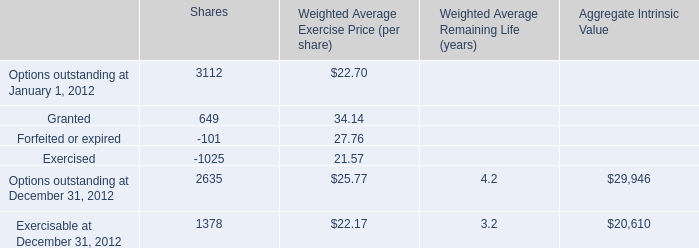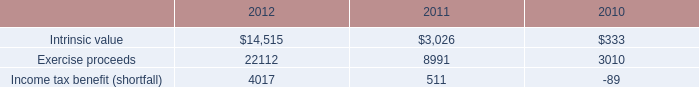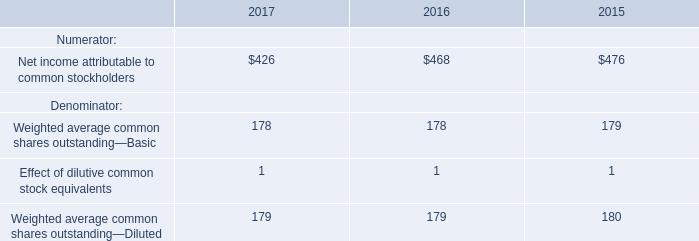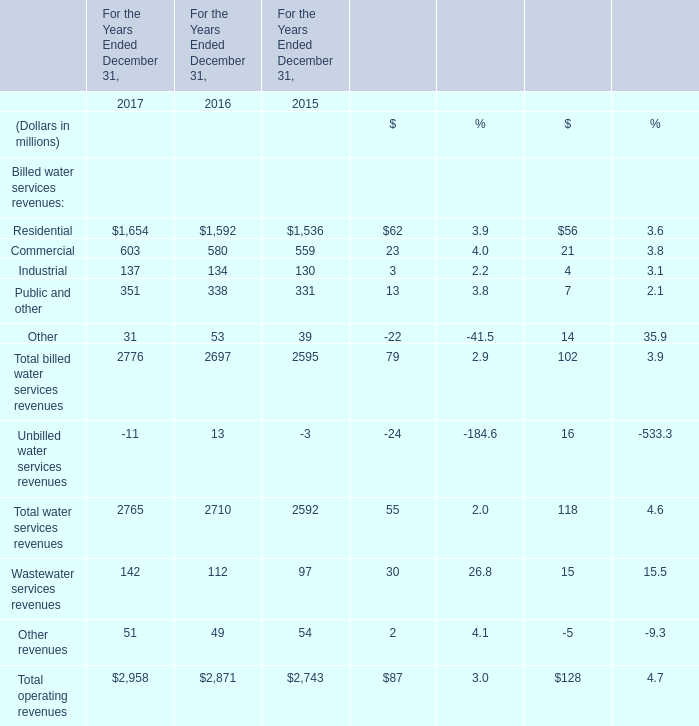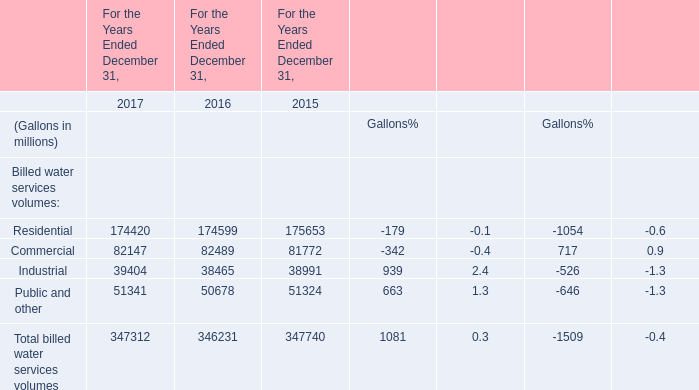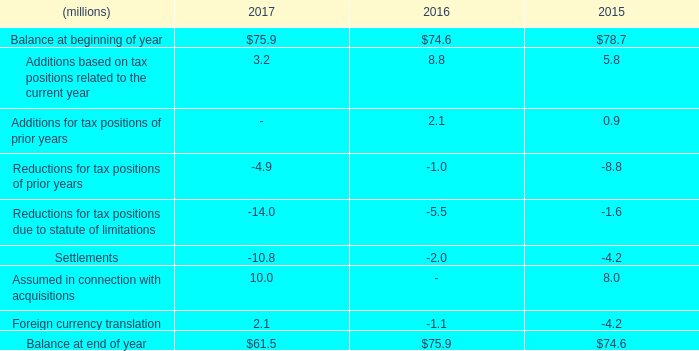What's the average of Industrial in 2017, 2016, and 2015? (in million) 
Computations: (((137 + 134) + 130) / 3)
Answer: 133.66667. 